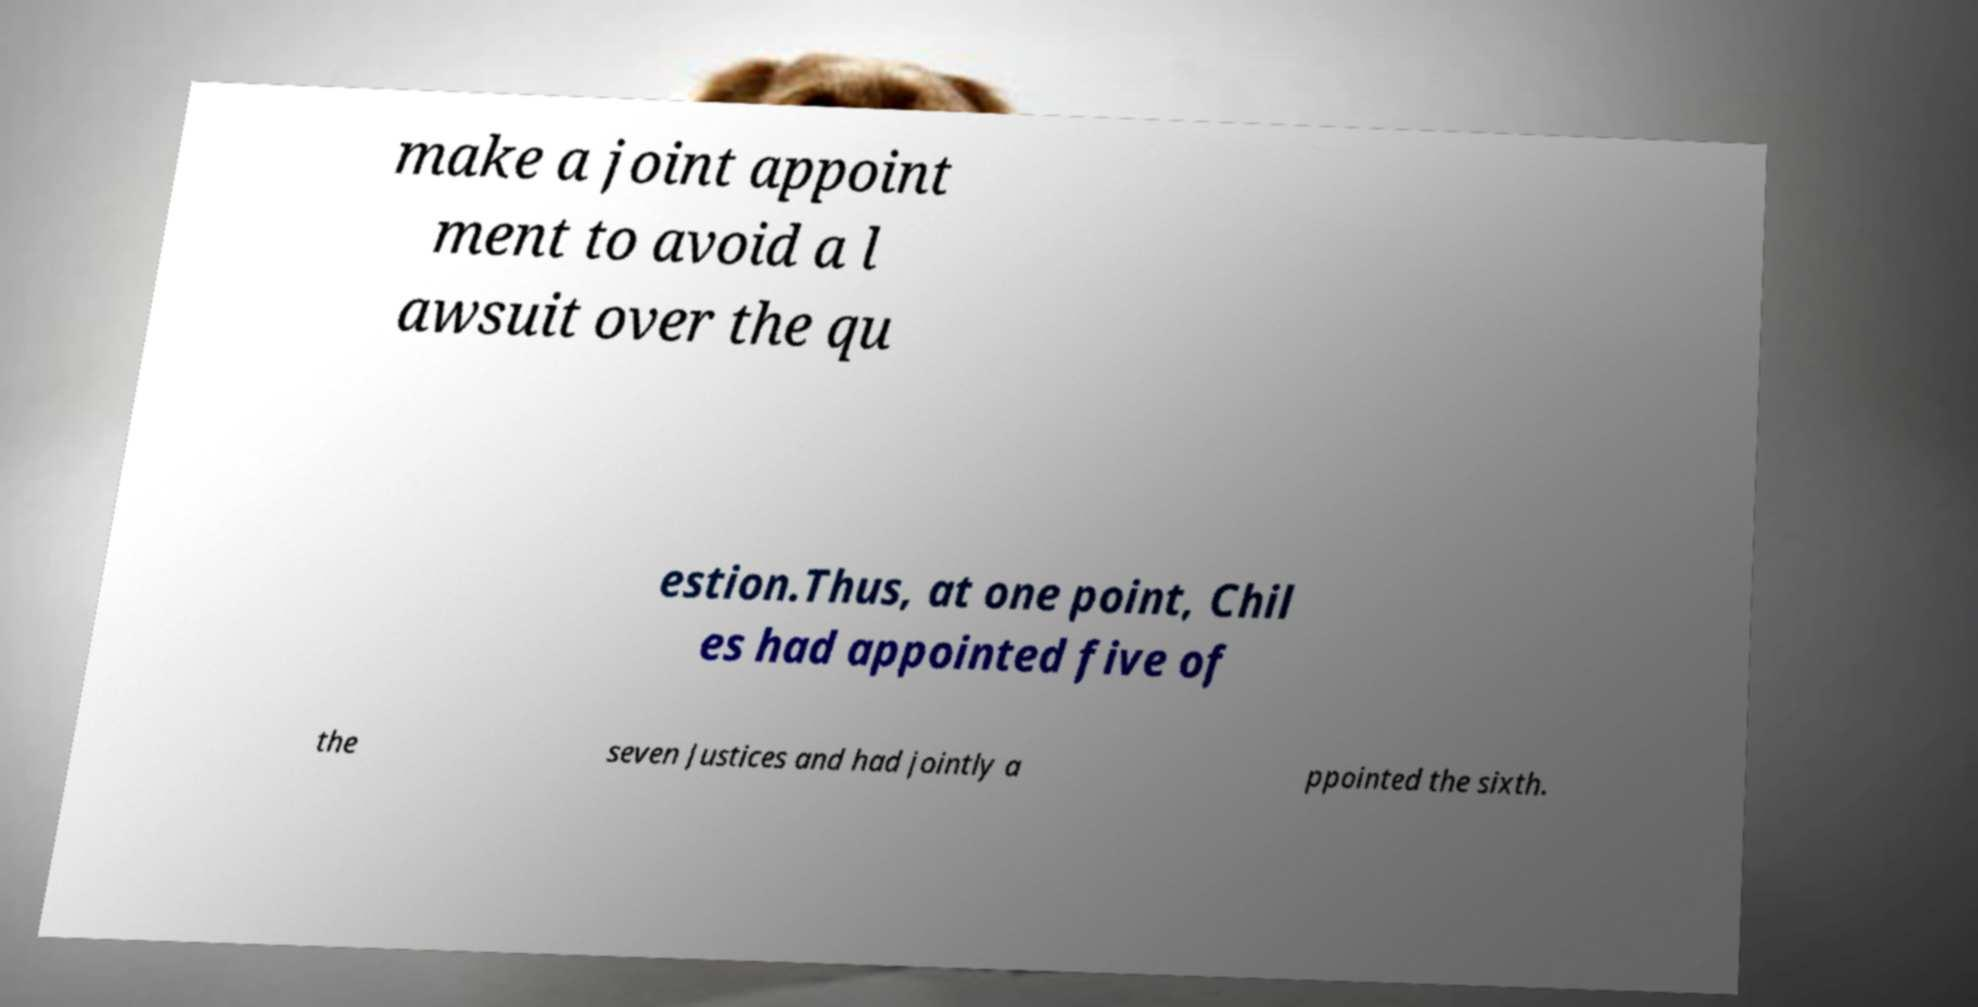There's text embedded in this image that I need extracted. Can you transcribe it verbatim? make a joint appoint ment to avoid a l awsuit over the qu estion.Thus, at one point, Chil es had appointed five of the seven Justices and had jointly a ppointed the sixth. 